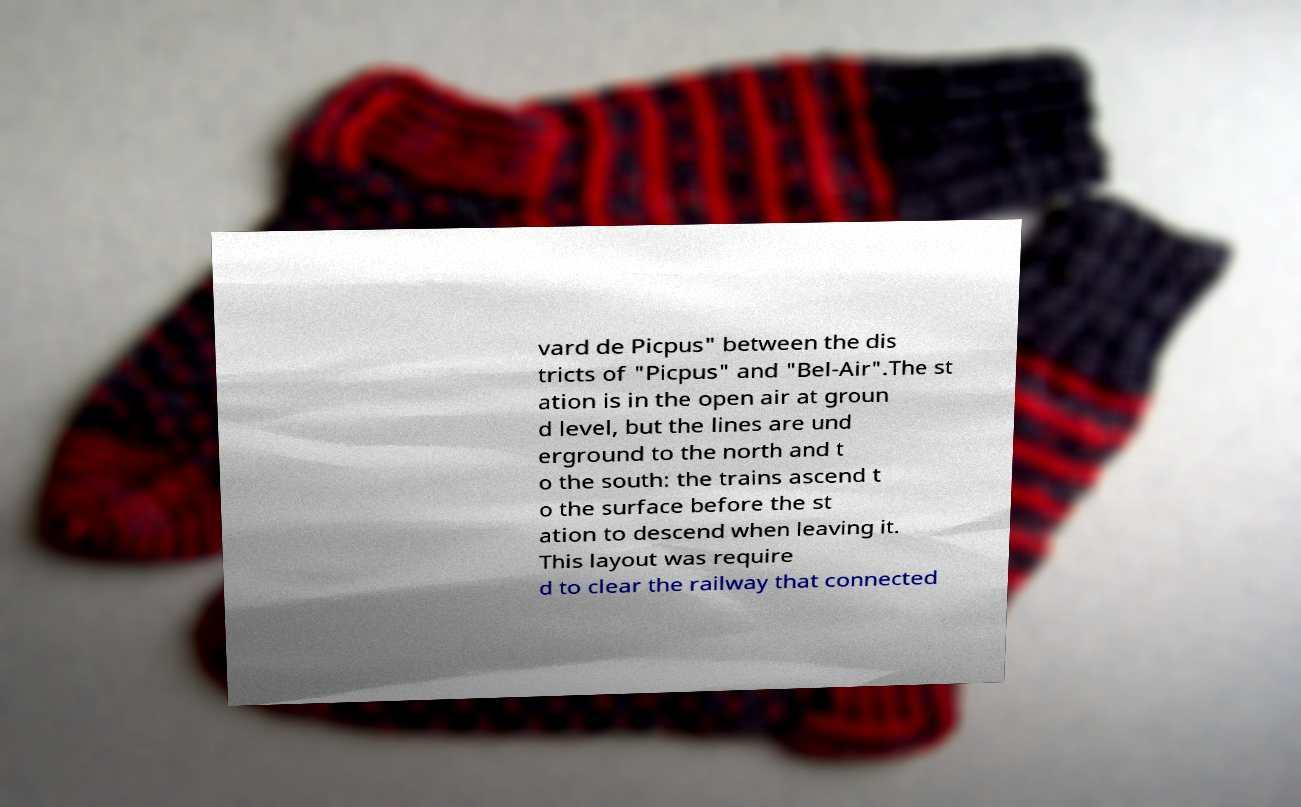Could you extract and type out the text from this image? vard de Picpus" between the dis tricts of "Picpus" and "Bel-Air".The st ation is in the open air at groun d level, but the lines are und erground to the north and t o the south: the trains ascend t o the surface before the st ation to descend when leaving it. This layout was require d to clear the railway that connected 